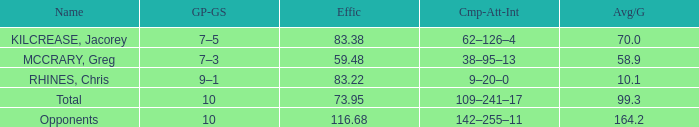What is the minimal efficacy with a 5 59.48. 